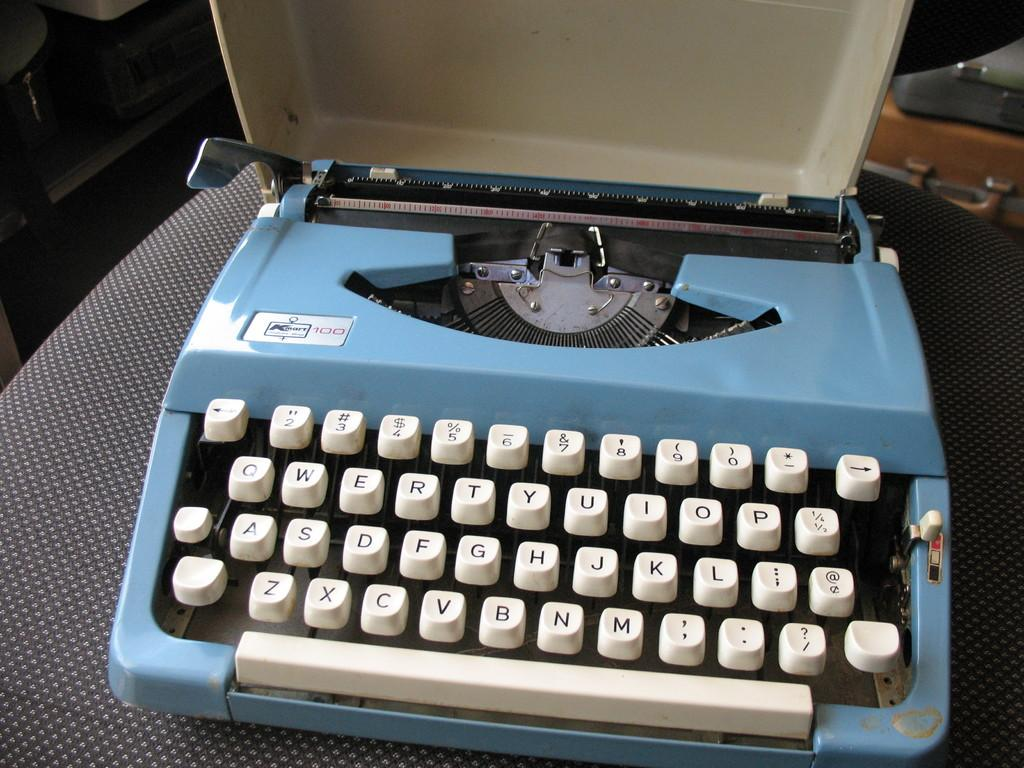Provide a one-sentence caption for the provided image. A blue typewriter with white keys such as the letters Z, X and C. 